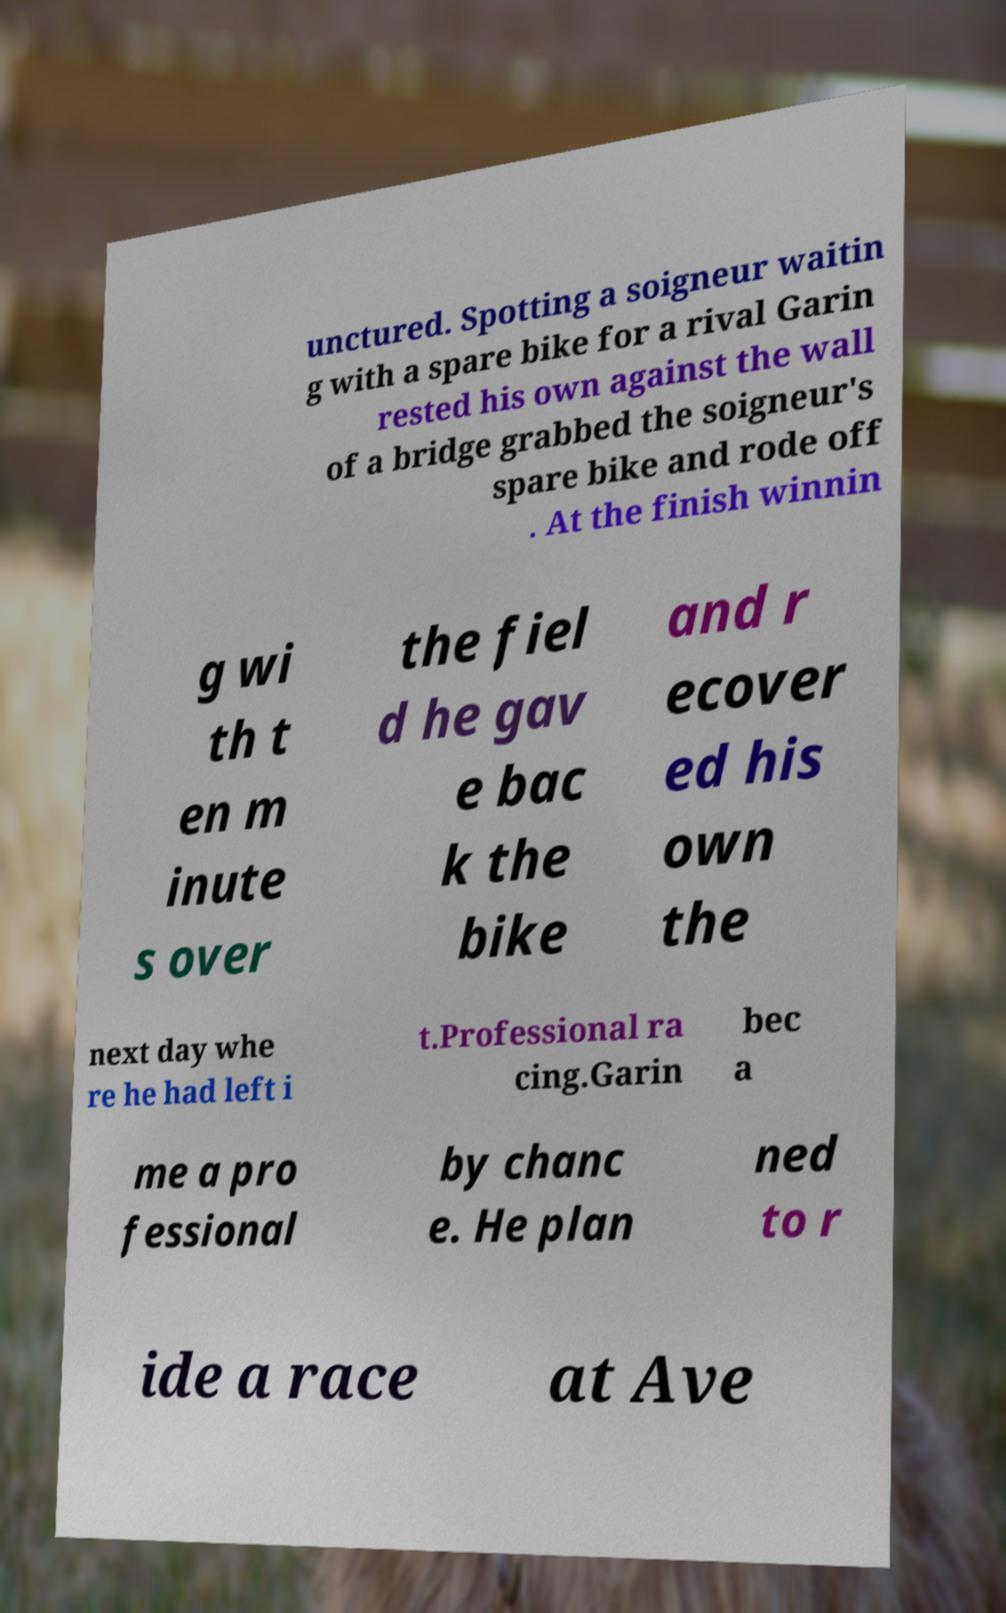There's text embedded in this image that I need extracted. Can you transcribe it verbatim? unctured. Spotting a soigneur waitin g with a spare bike for a rival Garin rested his own against the wall of a bridge grabbed the soigneur's spare bike and rode off . At the finish winnin g wi th t en m inute s over the fiel d he gav e bac k the bike and r ecover ed his own the next day whe re he had left i t.Professional ra cing.Garin bec a me a pro fessional by chanc e. He plan ned to r ide a race at Ave 